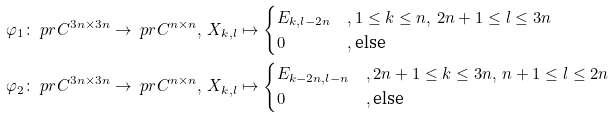<formula> <loc_0><loc_0><loc_500><loc_500>\varphi _ { 1 } & \colon \ p r C ^ { 3 n \times 3 n } \to \ p r C ^ { n \times n } , \, X _ { k , l } \mapsto \begin{cases} E _ { k , l - 2 n } & , 1 \leq k \leq n , \, 2 n + 1 \leq l \leq 3 n \\ 0 & , \text {else} \end{cases} \\ \varphi _ { 2 } & \colon \ p r C ^ { 3 n \times 3 n } \to \ p r C ^ { n \times n } , \, X _ { k , l } \mapsto \begin{cases} E _ { k - 2 n , l - n } & , 2 n + 1 \leq k \leq 3 n , \, n + 1 \leq l \leq 2 n \\ 0 & , \text {else} \end{cases}</formula> 